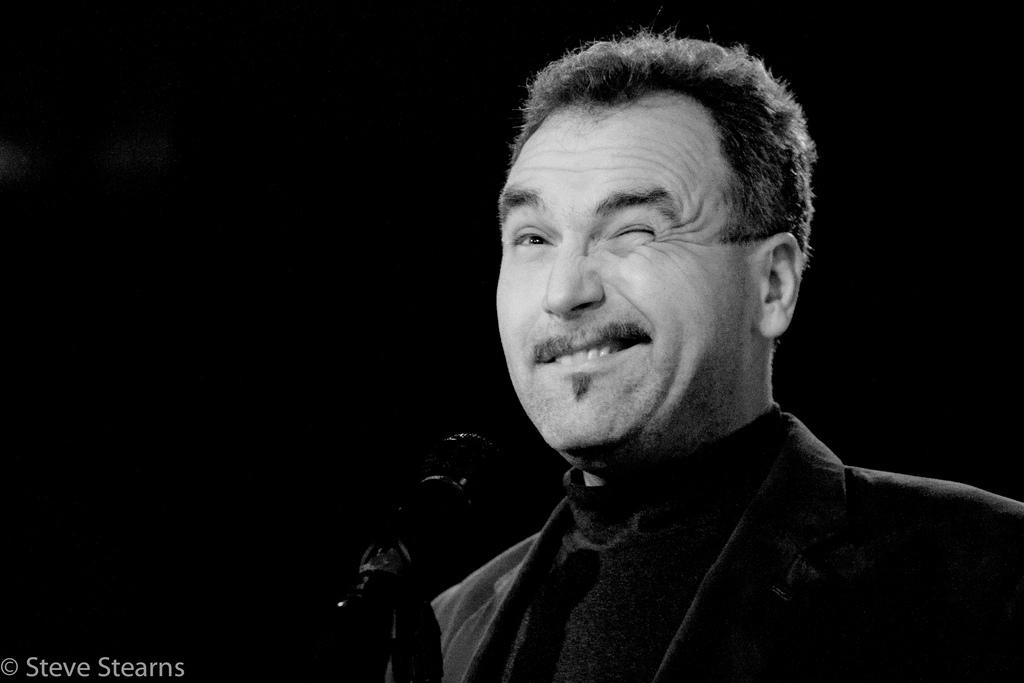Who is the main subject in the image? There is a man in the image. What is the man doing in the image? The man is winking. What object is in front of the man? There is a microphone in front of the man. What is the color of the background in the image? The background of the image is dark. Where is the text located in the image? The text is in the bottom left corner of the image. What type of stone is the man holding in the image? There is no stone present in the image; the man is holding a microphone. What flavor of toothpaste is the man using in the image? There is no toothpaste present in the image; the man is holding a microphone and winking. 